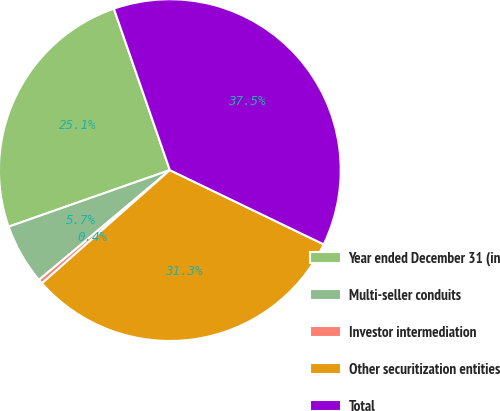Convert chart. <chart><loc_0><loc_0><loc_500><loc_500><pie_chart><fcel>Year ended December 31 (in<fcel>Multi-seller conduits<fcel>Investor intermediation<fcel>Other securitization entities<fcel>Total<nl><fcel>25.06%<fcel>5.74%<fcel>0.42%<fcel>31.31%<fcel>37.47%<nl></chart> 